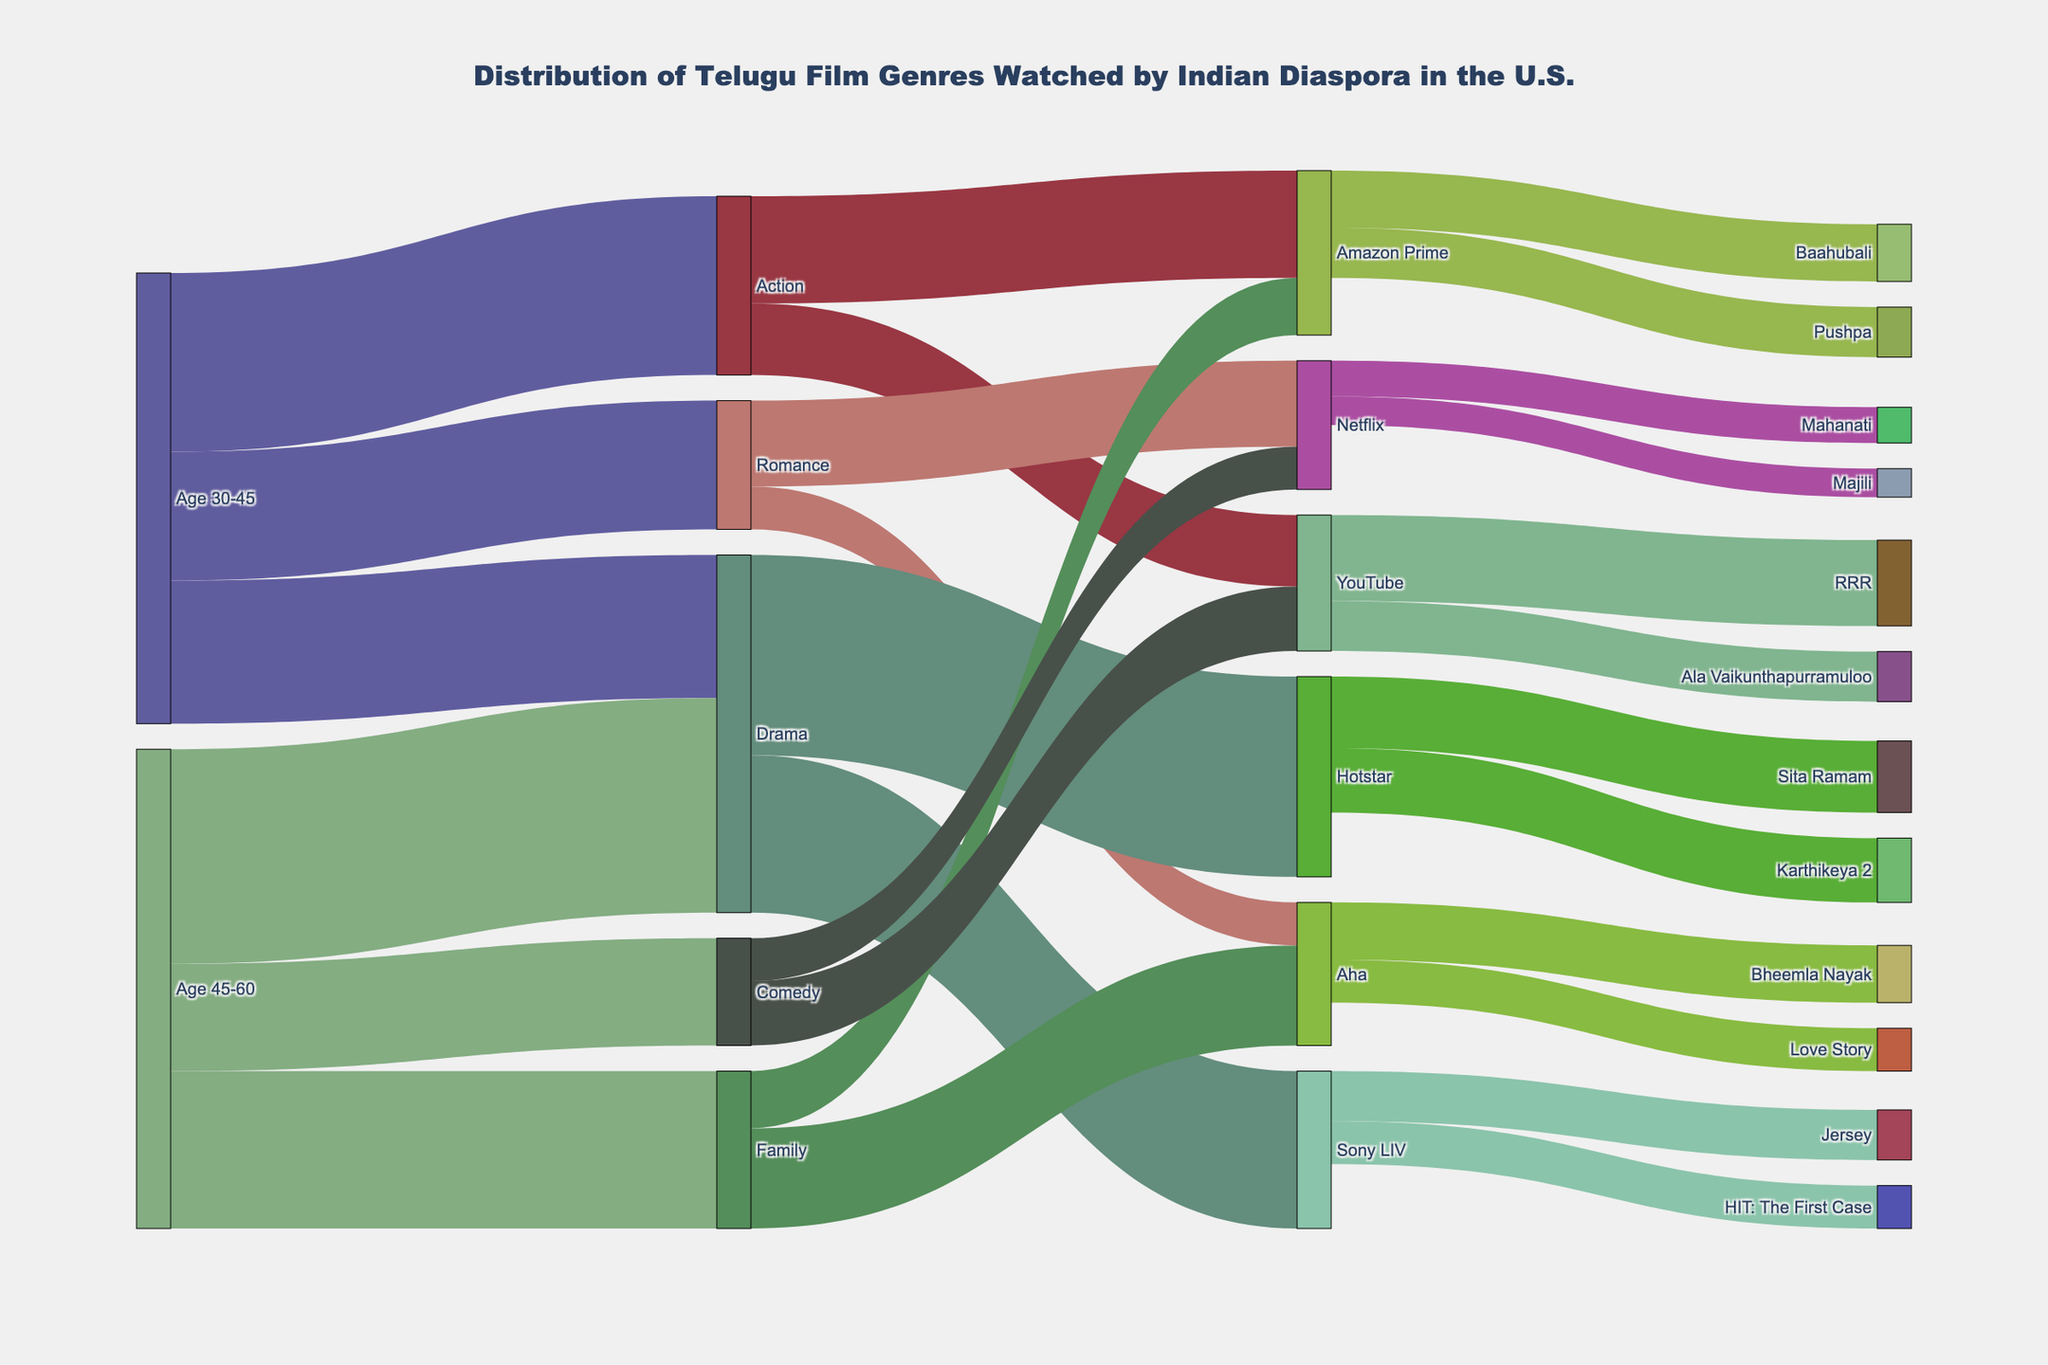Which age group watches more drama films? Look at the connections between age groups and genres. Compare the values for 'Drama'. Age 45-60 watches 300 whereas Age 30-45 watches 200.
Answer: Age 45-60 What is the total number of action films watched across all platforms? Trace the connections from 'Action' to different platforms. Sum the values: 150 (Amazon Prime) + 100 (YouTube) = 250
Answer: 250 Which genre is most frequently watched by the age group 45-60? Look for the largest value associated with age group 45-60. Drama has the highest value of 300.
Answer: Drama What is the combined number of films watched on Amazon Prime from all genres? Follow the connections leading to Amazon Prime and sum the values: Action (150) + Family (80) = 230
Answer: 230 Which platform shows more comedy films? Compare the values of 'Comedy' going to different platforms. YouTube (90) vs. Netflix (60).
Answer: YouTube What is the most watched film on Hotstar? Trace the connections from Hotstar to individual films and identify the one with the highest value. Sita Ramam (100) is higher than Karthikeya 2 (90).
Answer: Sita Ramam How many family films are watched by the age group 45-60 on Aha? Find the connection from 'Family' to 'Aha' related to age group 45-60. The value is 140.
Answer: 140 Which age group watches more genres on Netflix? Compare the connections leading from both age groups to Netflix. Age 30-45 has 120 (Romance) and Age 45-60 has 60 (Comedy), so Age 30-45 watches more.
Answer: Age 30-45 What is the total number of films watched by the age group 30-45 across all genres? Sum all the values for age group 30-45: Action (250) + Romance (180) + Drama (200) = 630
Answer: 630 Which film on YouTube has the highest number of viewers? Compare the viewer numbers of films on YouTube. RRR has 120 and Ala Vaikunthapurramuloo has 70.
Answer: RRR 